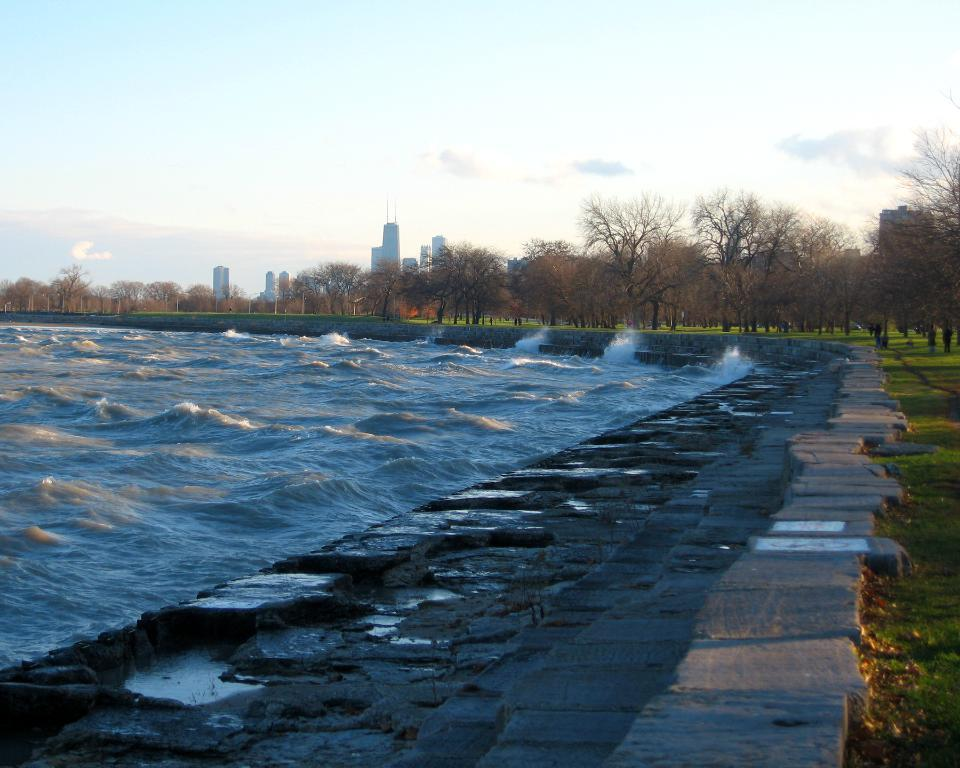What type of natural environment is visible in the image? There is grass, water, trees, and stones in the image, which suggests a natural environment. What architectural features can be seen in the image? There are steps and buildings visible in the image. What is the background of the image? The sky is visible in the background of the image. Where is the sofa located in the image? There is no sofa present in the image. How many houses are visible in the image? The term "houses" is not mentioned in the provided facts, but there are buildings visible in the image. 